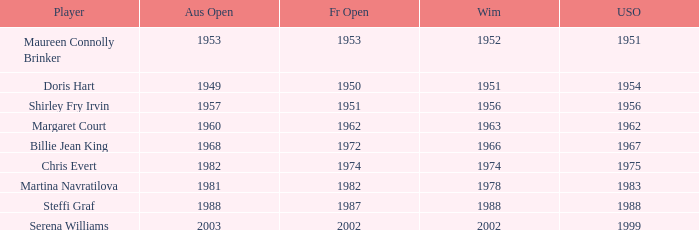When did Shirley Fry Irvin win the US Open? 1956.0. 